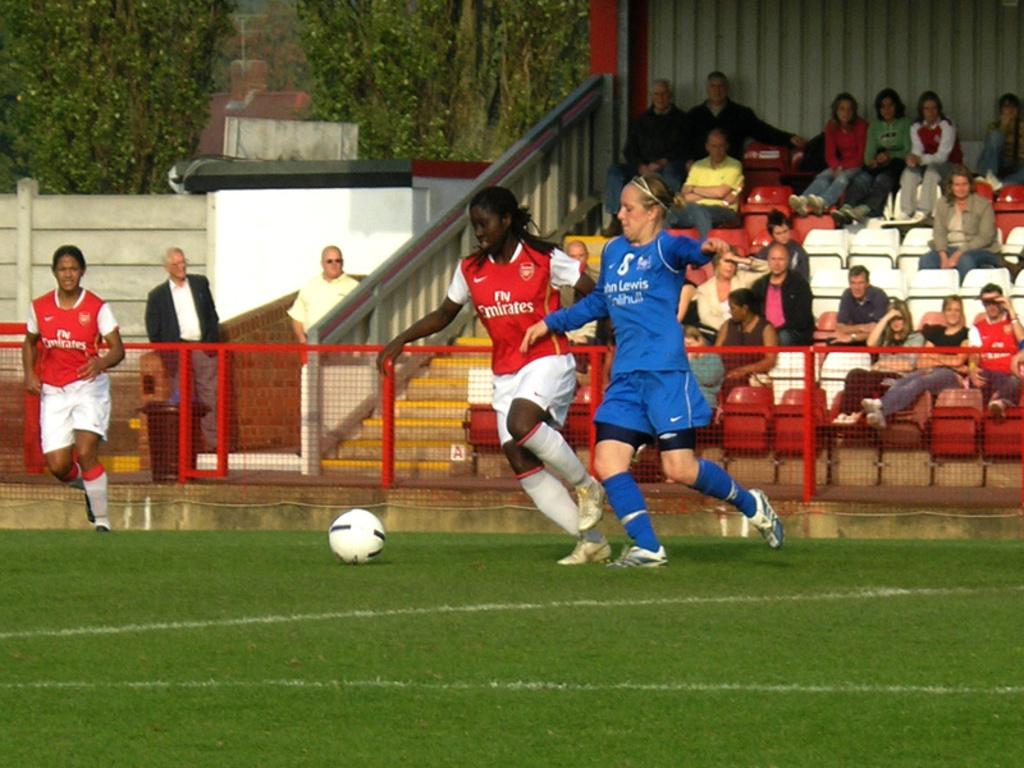<image>
Relay a brief, clear account of the picture shown. Women playing soccer, the one in the blue shirt has Lewis written on it. 